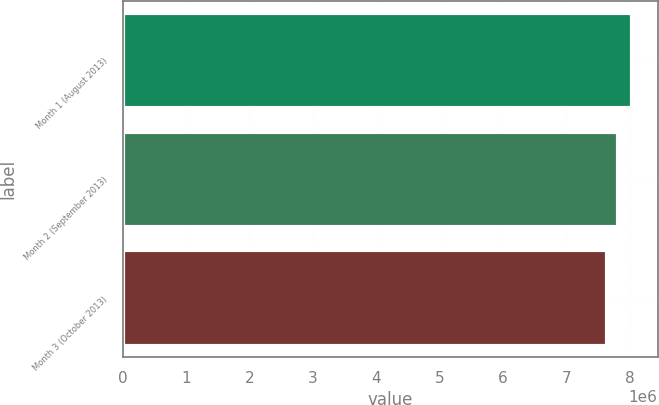<chart> <loc_0><loc_0><loc_500><loc_500><bar_chart><fcel>Month 1 (August 2013)<fcel>Month 2 (September 2013)<fcel>Month 3 (October 2013)<nl><fcel>8.03602e+06<fcel>7.81041e+06<fcel>7.64485e+06<nl></chart> 